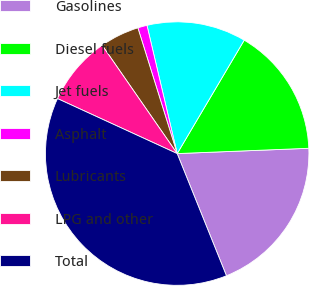<chart> <loc_0><loc_0><loc_500><loc_500><pie_chart><fcel>Gasolines<fcel>Diesel fuels<fcel>Jet fuels<fcel>Asphalt<fcel>Lubricants<fcel>LPG and other<fcel>Total<nl><fcel>19.54%<fcel>15.86%<fcel>12.18%<fcel>1.14%<fcel>4.82%<fcel>8.5%<fcel>37.95%<nl></chart> 